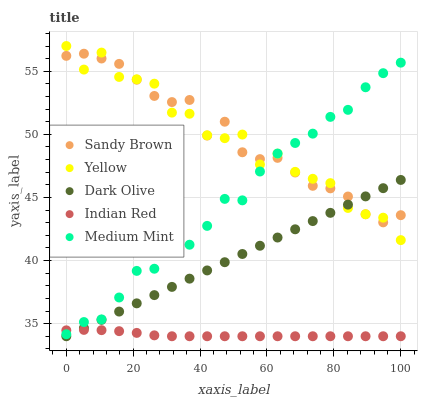Does Indian Red have the minimum area under the curve?
Answer yes or no. Yes. Does Sandy Brown have the maximum area under the curve?
Answer yes or no. Yes. Does Dark Olive have the minimum area under the curve?
Answer yes or no. No. Does Dark Olive have the maximum area under the curve?
Answer yes or no. No. Is Dark Olive the smoothest?
Answer yes or no. Yes. Is Yellow the roughest?
Answer yes or no. Yes. Is Sandy Brown the smoothest?
Answer yes or no. No. Is Sandy Brown the roughest?
Answer yes or no. No. Does Dark Olive have the lowest value?
Answer yes or no. Yes. Does Sandy Brown have the lowest value?
Answer yes or no. No. Does Yellow have the highest value?
Answer yes or no. Yes. Does Dark Olive have the highest value?
Answer yes or no. No. Is Indian Red less than Sandy Brown?
Answer yes or no. Yes. Is Medium Mint greater than Dark Olive?
Answer yes or no. Yes. Does Sandy Brown intersect Dark Olive?
Answer yes or no. Yes. Is Sandy Brown less than Dark Olive?
Answer yes or no. No. Is Sandy Brown greater than Dark Olive?
Answer yes or no. No. Does Indian Red intersect Sandy Brown?
Answer yes or no. No. 